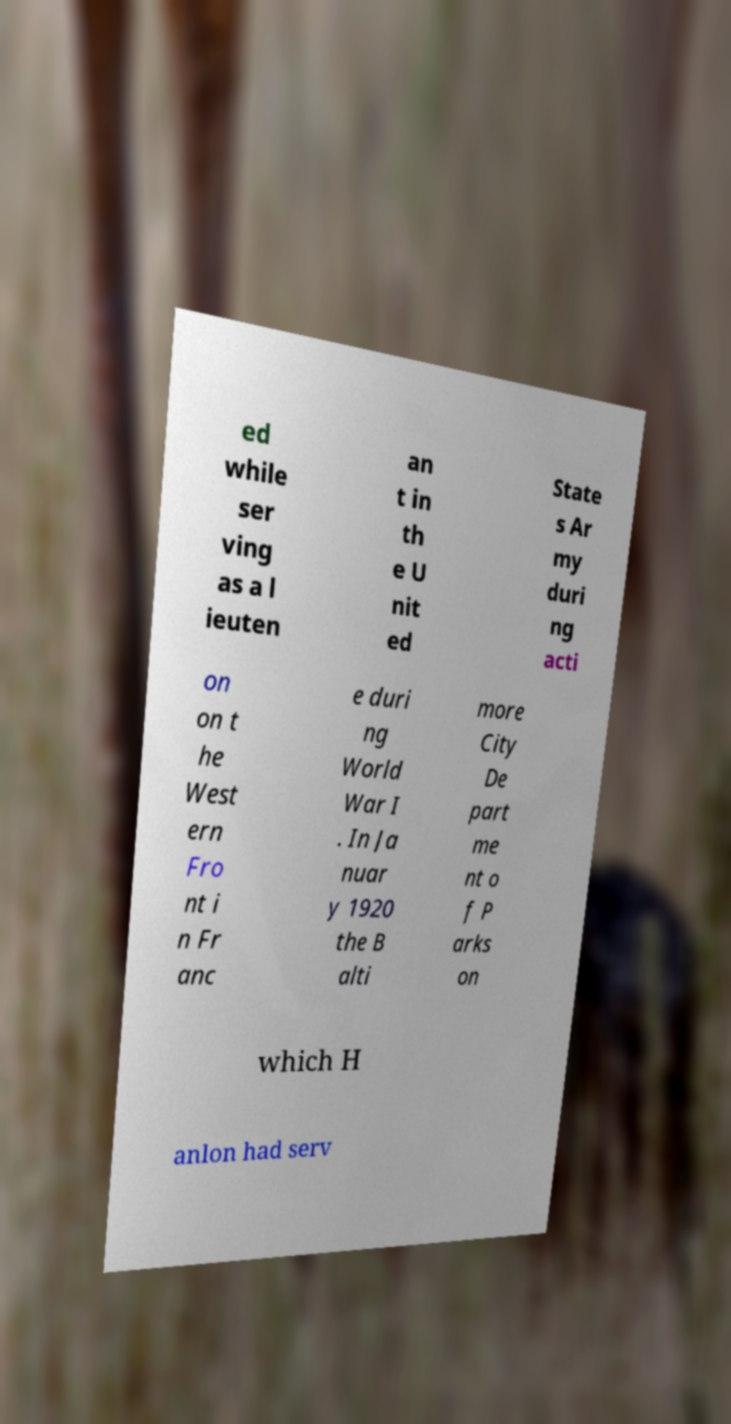Please read and relay the text visible in this image. What does it say? ed while ser ving as a l ieuten an t in th e U nit ed State s Ar my duri ng acti on on t he West ern Fro nt i n Fr anc e duri ng World War I . In Ja nuar y 1920 the B alti more City De part me nt o f P arks on which H anlon had serv 